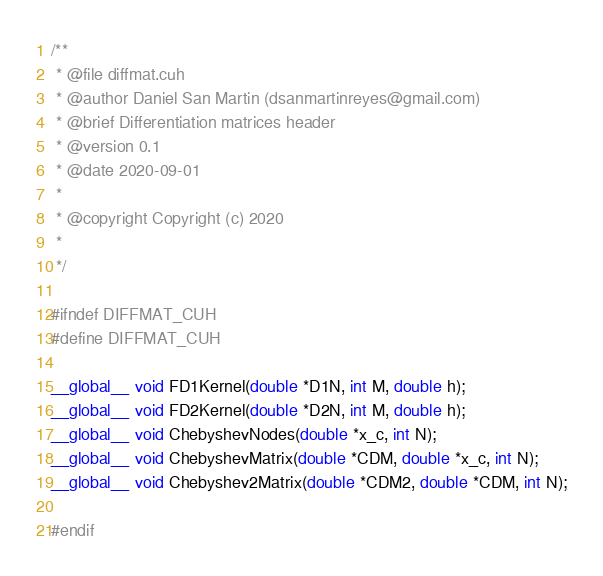Convert code to text. <code><loc_0><loc_0><loc_500><loc_500><_Cuda_>/**
 * @file diffmat.cuh
 * @author Daniel San Martin (dsanmartinreyes@gmail.com)
 * @brief Differentiation matrices header
 * @version 0.1
 * @date 2020-09-01
 * 
 * @copyright Copyright (c) 2020
 * 
 */
 
#ifndef DIFFMAT_CUH
#define DIFFMAT_CUH

__global__ void FD1Kernel(double *D1N, int M, double h);
__global__ void FD2Kernel(double *D2N, int M, double h);
__global__ void ChebyshevNodes(double *x_c, int N);
__global__ void ChebyshevMatrix(double *CDM, double *x_c, int N);
__global__ void Chebyshev2Matrix(double *CDM2, double *CDM, int N);

#endif
</code> 